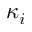<formula> <loc_0><loc_0><loc_500><loc_500>\kappa _ { i }</formula> 